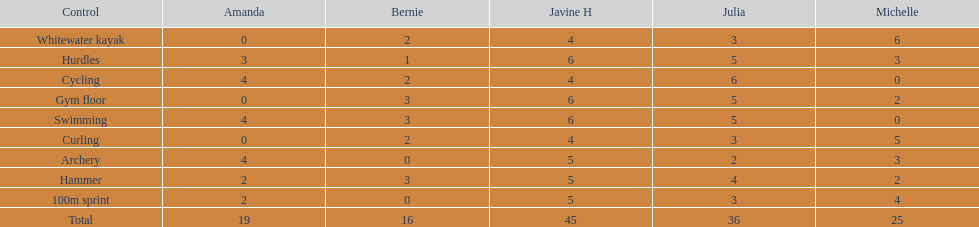What is the first discipline listed on this chart? Whitewater kayak. 